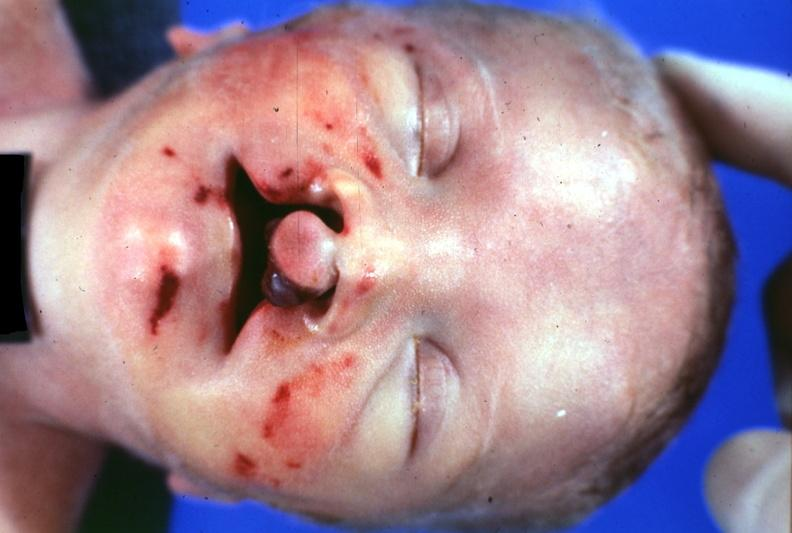what does this image show?
Answer the question using a single word or phrase. Close-up of head typical 